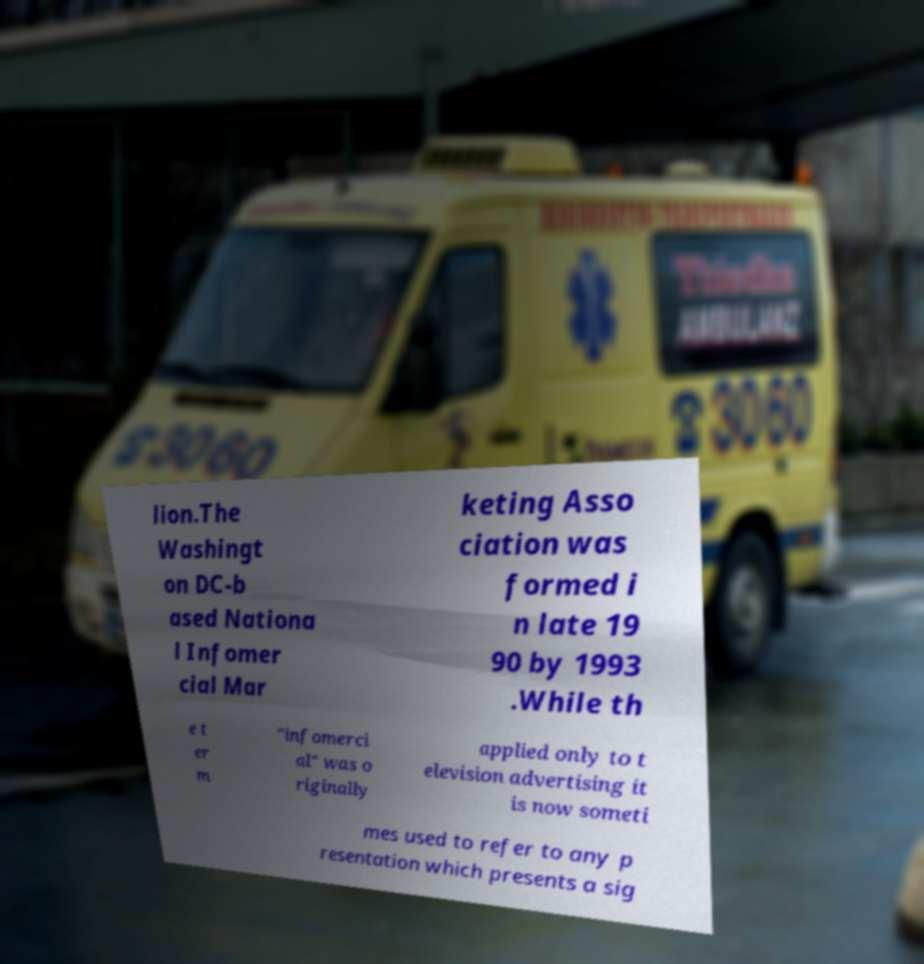What messages or text are displayed in this image? I need them in a readable, typed format. lion.The Washingt on DC-b ased Nationa l Infomer cial Mar keting Asso ciation was formed i n late 19 90 by 1993 .While th e t er m "infomerci al" was o riginally applied only to t elevision advertising it is now someti mes used to refer to any p resentation which presents a sig 